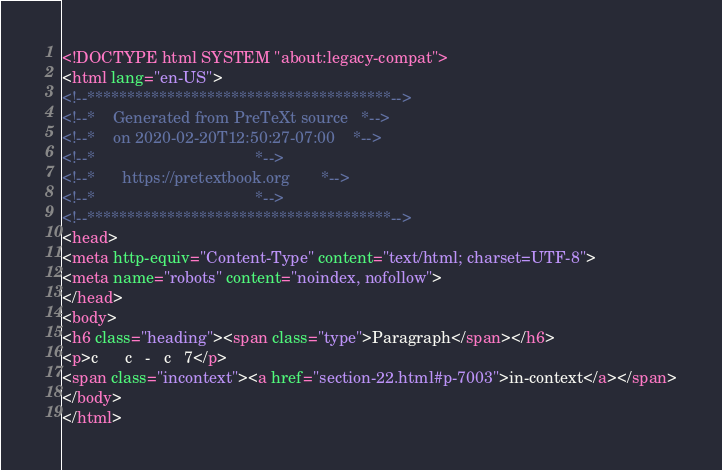<code> <loc_0><loc_0><loc_500><loc_500><_HTML_><!DOCTYPE html SYSTEM "about:legacy-compat">
<html lang="en-US">
<!--**************************************-->
<!--*    Generated from PreTeXt source   *-->
<!--*    on 2020-02-20T12:50:27-07:00    *-->
<!--*                                    *-->
<!--*      https://pretextbook.org       *-->
<!--*                                    *-->
<!--**************************************-->
<head>
<meta http-equiv="Content-Type" content="text/html; charset=UTF-8">
<meta name="robots" content="noindex, nofollow">
</head>
<body>
<h6 class="heading"><span class="type">Paragraph</span></h6>
<p>c      c   -   c   7</p>
<span class="incontext"><a href="section-22.html#p-7003">in-context</a></span>
</body>
</html>
</code> 